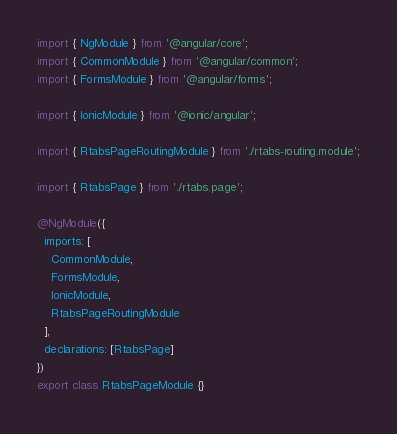<code> <loc_0><loc_0><loc_500><loc_500><_TypeScript_>import { NgModule } from '@angular/core';
import { CommonModule } from '@angular/common';
import { FormsModule } from '@angular/forms';

import { IonicModule } from '@ionic/angular';

import { RtabsPageRoutingModule } from './rtabs-routing.module';

import { RtabsPage } from './rtabs.page';

@NgModule({
  imports: [
    CommonModule,
    FormsModule,
    IonicModule,
    RtabsPageRoutingModule
  ],
  declarations: [RtabsPage]
})
export class RtabsPageModule {}
</code> 